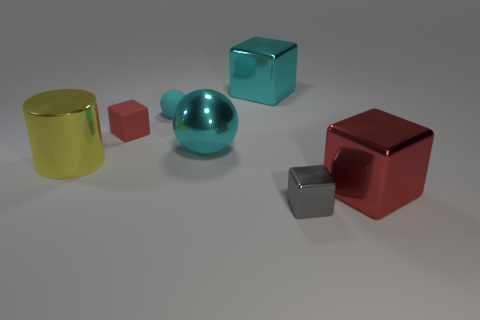There is a thing that is both right of the big cyan cube and behind the tiny gray block; how big is it?
Your response must be concise. Large. Do the small object that is in front of the big shiny ball and the big object that is in front of the big yellow metallic cylinder have the same shape?
Your answer should be compact. Yes. What shape is the tiny object that is the same color as the shiny ball?
Make the answer very short. Sphere. How many small red things are the same material as the big red cube?
Keep it short and to the point. 0. What is the shape of the object that is on the left side of the gray metal thing and in front of the big cyan ball?
Give a very brief answer. Cylinder. Do the big cyan object in front of the tiny red matte block and the big cyan cube have the same material?
Your answer should be compact. Yes. Is there any other thing that is the same material as the tiny ball?
Offer a terse response. Yes. What is the color of the metallic sphere that is the same size as the metallic cylinder?
Offer a very short reply. Cyan. Is there another matte sphere that has the same color as the small rubber sphere?
Keep it short and to the point. No. There is a cube that is made of the same material as the tiny ball; what is its size?
Make the answer very short. Small. 